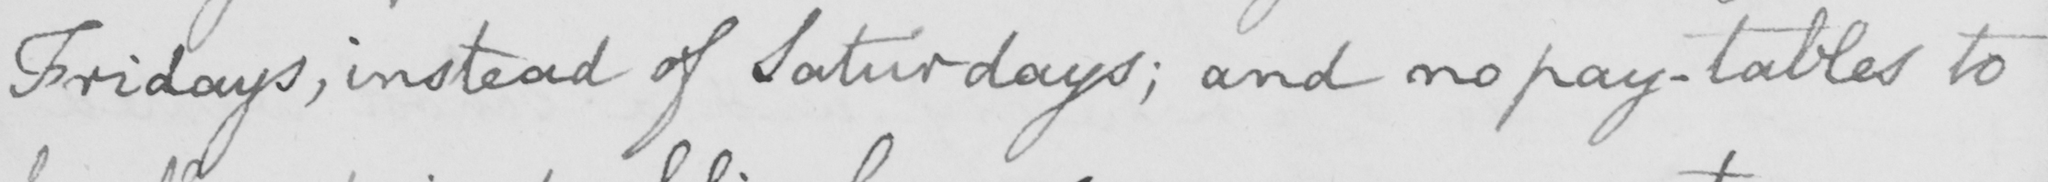What does this handwritten line say? Fridays , instead of Saturdays ; and no pay-tables to 